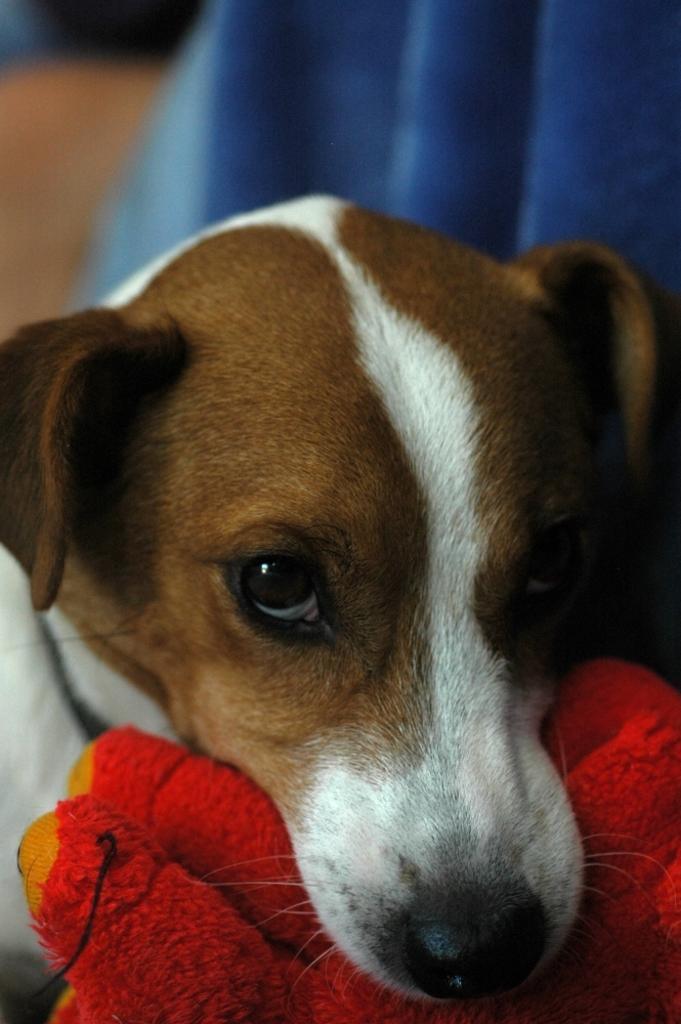How would you summarize this image in a sentence or two? In this picture I can see a dog, It is white and brown in color and I can see red color cloth and in the background, it looks like a blue color cloth. 